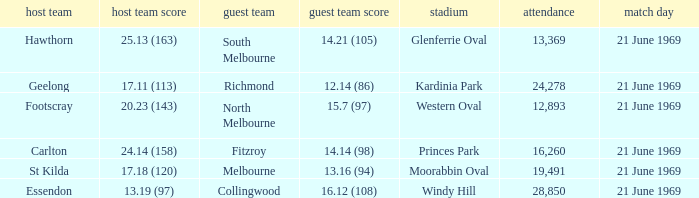What is Essendon's home team that has an away crowd size larger than 19,491? Collingwood. 